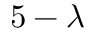Convert formula to latex. <formula><loc_0><loc_0><loc_500><loc_500>5 - \lambda</formula> 